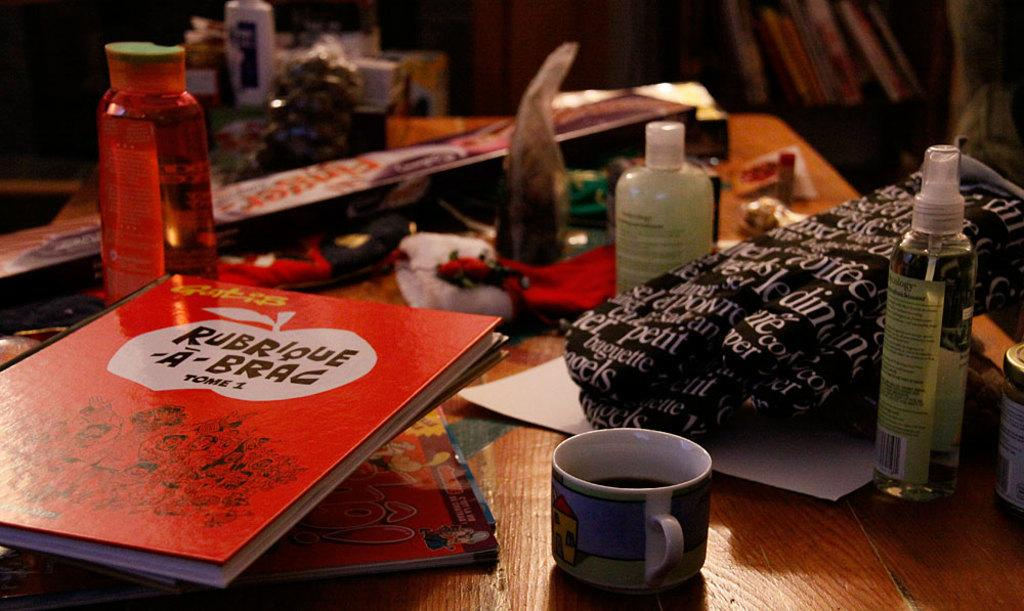<image>
Describe the image concisely. An orange book titled Rubrioue A Brac is on a wooden table. 